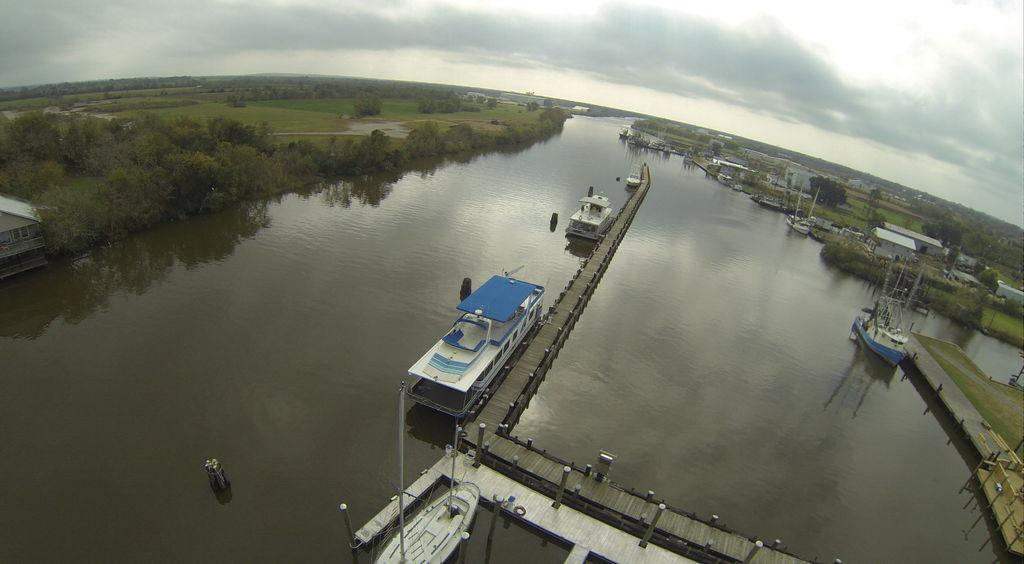What is in the water in the image? There are boats in the water in the image. What can be seen on either side of the water? There are trees on either side of the water. What is located in the right corner of the image? There are buildings in the right corner of the image. What type of bag can be seen hanging from the trees in the image? There are no bags present in the image; it features boats in the water and trees on either side. What color is the copper tree in the image? There is no copper tree present in the image; the trees are not made of copper. 